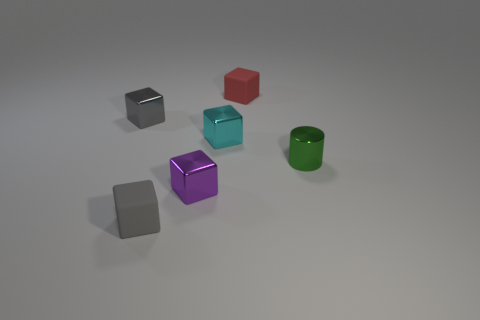Is the number of small blocks in front of the purple shiny object less than the number of tiny metallic blocks in front of the red matte thing?
Offer a terse response. Yes. What is the material of the small cyan thing that is the same shape as the small gray matte thing?
Offer a terse response. Metal. What shape is the tiny purple thing that is made of the same material as the green thing?
Keep it short and to the point. Cube. What number of green things are the same shape as the small purple metallic object?
Your answer should be very brief. 0. There is a small gray thing on the left side of the matte block in front of the small cylinder; what is its shape?
Make the answer very short. Cube. There is a gray cube that is in front of the purple shiny object; is its size the same as the small gray shiny block?
Provide a short and direct response. Yes. There is a metallic cube that is right of the small gray rubber cube and behind the tiny green cylinder; what is its size?
Your answer should be compact. Small. What number of gray cubes have the same size as the red rubber object?
Keep it short and to the point. 2. There is a tiny matte cube that is behind the small green cylinder; what number of small green shiny things are in front of it?
Offer a terse response. 1. Is there a gray object in front of the gray metal object behind the thing right of the red object?
Offer a terse response. Yes. 